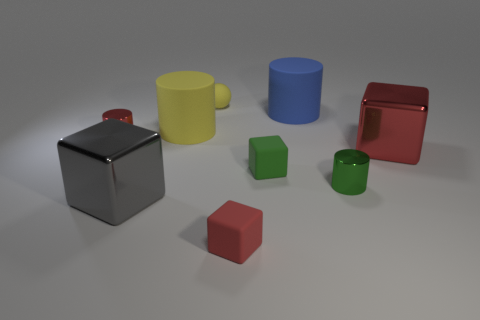Add 1 big red shiny blocks. How many objects exist? 10 Subtract all balls. How many objects are left? 8 Subtract all small blue metal blocks. Subtract all small matte spheres. How many objects are left? 8 Add 2 green shiny cylinders. How many green shiny cylinders are left? 3 Add 4 tiny cyan matte cylinders. How many tiny cyan matte cylinders exist? 4 Subtract 0 gray spheres. How many objects are left? 9 